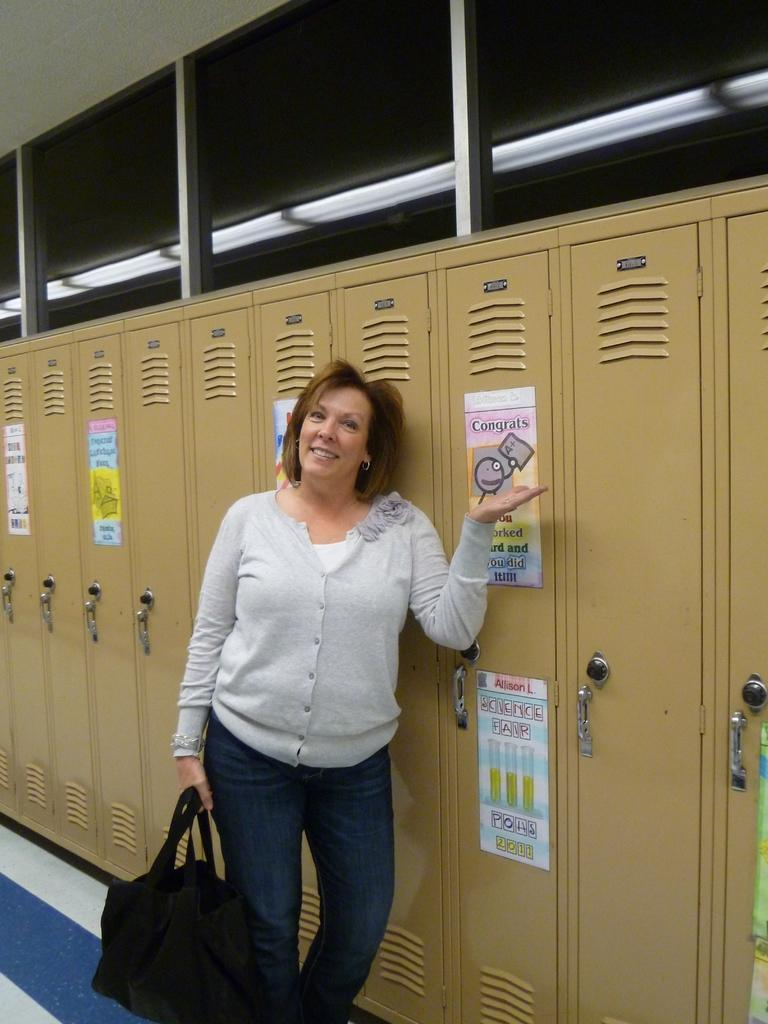Who is present in the image? There is a woman in the image. What is the woman doing in the image? The woman is standing in the image. What is the woman holding in her hand? The woman is holding a bag in her hand. What type of furniture can be seen in the image? There are cupboards visible in the image. What is on the cupboards? There are posters on the cupboards. What type of grip does the woman have on the field in the image? There is no field present in the image, and the woman is not gripping anything. 